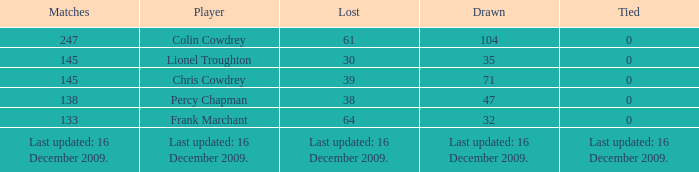Show me the list where there are 0 ties and 47 games drawn. 38.0. 